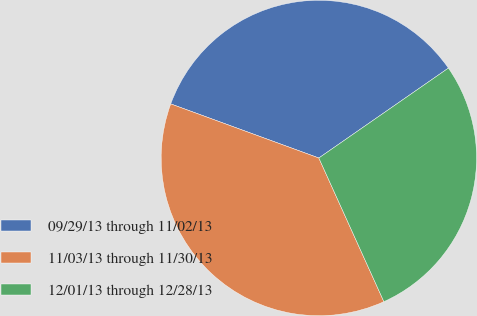Convert chart to OTSL. <chart><loc_0><loc_0><loc_500><loc_500><pie_chart><fcel>09/29/13 through 11/02/13<fcel>11/03/13 through 11/30/13<fcel>12/01/13 through 12/28/13<nl><fcel>34.77%<fcel>37.34%<fcel>27.89%<nl></chart> 